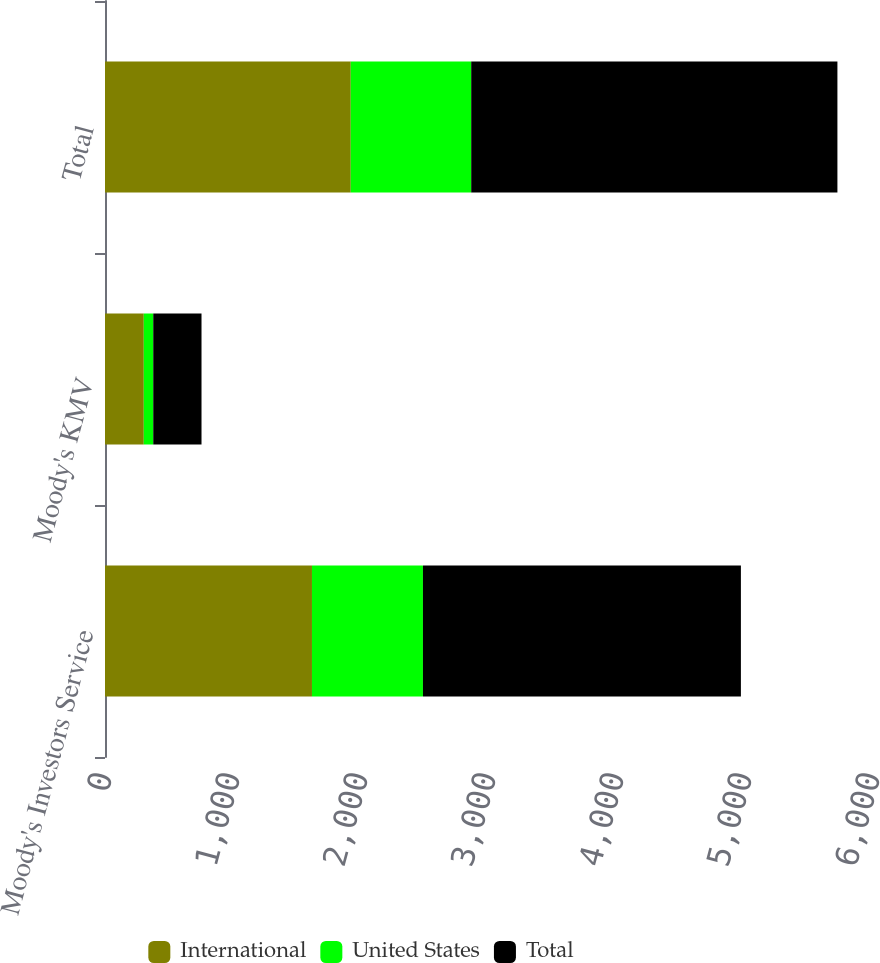Convert chart. <chart><loc_0><loc_0><loc_500><loc_500><stacked_bar_chart><ecel><fcel>Moody's Investors Service<fcel>Moody's KMV<fcel>Total<nl><fcel>International<fcel>1617<fcel>303<fcel>1920<nl><fcel>United States<fcel>867<fcel>74<fcel>941<nl><fcel>Total<fcel>2484<fcel>377<fcel>2861<nl></chart> 